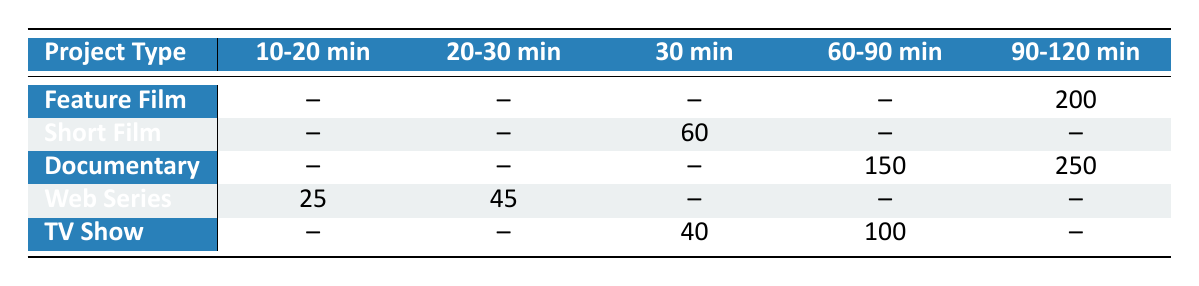What is the editing time for a Feature Film that has a movie length of 90-120 minutes? According to the table, the editing time for a Feature Film with a movie length of 90-120 minutes is directly listed as 200 hours.
Answer: 200 hours Which project type has the lowest editing time for a movie length of 30 minutes? The table shows that the Short Film has an editing time of 60 hours for a 30-minute movie, while the TV Show has an editing time of 40 hours. Therefore, the lowest editing time is actually for the TV Show.
Answer: TV Show How many hours does it take to edit a Web Series with a movie length of 10-20 minutes? The table states that the editing time for a Web Series with a movie length of 10-20 minutes is 25 hours.
Answer: 25 hours What is the total editing time for all documentaries listed in the table? The editing times for documentaries are 150 hours (60-90 minutes) and 250 hours (90-120 minutes). Summing these gives 150 + 250 = 400 hours.
Answer: 400 hours Is the editing time for a TV Show with a length of 60 minutes more than 80 hours? The table shows that the editing time for a TV Show with a length of 60 minutes is 100 hours, which is indeed more than 80 hours.
Answer: Yes What is the average editing time for all project types with a movie length of 90-120 minutes? The editing times for project types that have a movie length of 90-120 minutes are 200 hours (Feature Film) and 250 hours (Documentary). The average is calculated as (200 + 250) / 2 = 225 hours.
Answer: 225 hours Which project type has the longest editing time for a specific movie length? The documentary with a movie length of 90-120 minutes has the longest editing time at 250 hours. Comparatively, the Feature Film’s editing time of 200 hours for the same movie length is lower.
Answer: Documentary How many project types have editing times listed for movie lengths shorter than 30 minutes? Analyzing the table, the Web Series has editing times for 10-20 minutes (25 hours) and 20-30 minutes (45 hours). No other project types list editing times for movie lengths shorter than 30 minutes. Therefore, there is only 1 project type.
Answer: 1 Are there any editing times recorded for movie lengths longer than 150 minutes in the table? Looking at the table, no project types have editing times recorded for movie lengths longer than 150 minutes; all entries are within the specified lengths.
Answer: No 